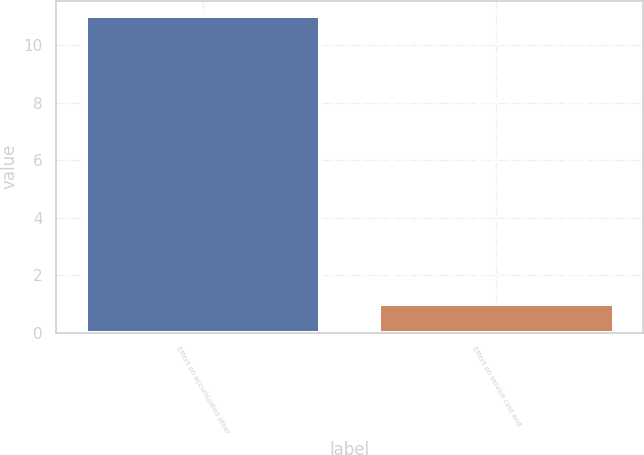Convert chart to OTSL. <chart><loc_0><loc_0><loc_500><loc_500><bar_chart><fcel>Effect on accumulated other<fcel>Effect on service cost and<nl><fcel>11<fcel>1<nl></chart> 